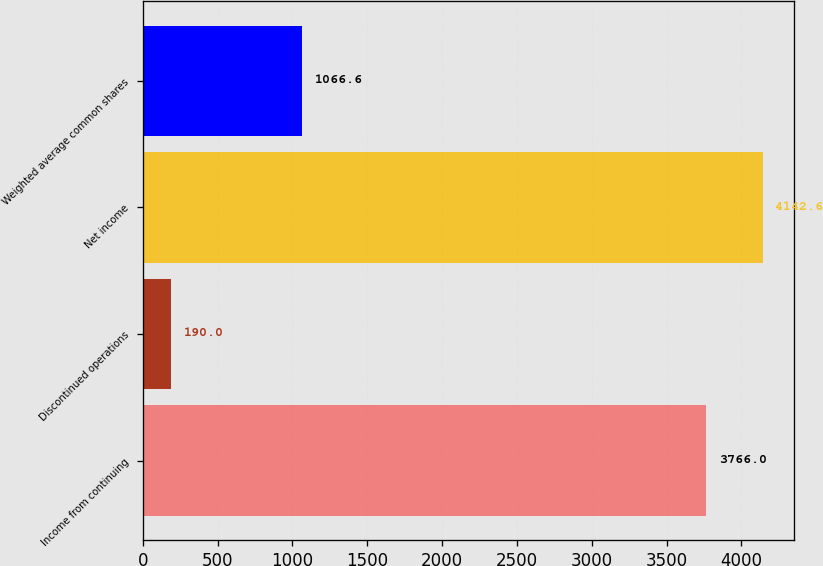Convert chart. <chart><loc_0><loc_0><loc_500><loc_500><bar_chart><fcel>Income from continuing<fcel>Discontinued operations<fcel>Net income<fcel>Weighted average common shares<nl><fcel>3766<fcel>190<fcel>4142.6<fcel>1066.6<nl></chart> 